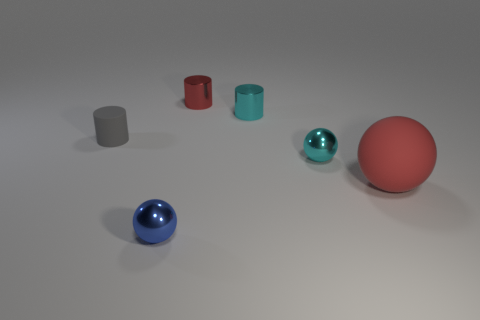Subtract all brown spheres. Subtract all red cylinders. How many spheres are left? 3 Add 4 small gray cylinders. How many objects exist? 10 Subtract 0 purple balls. How many objects are left? 6 Subtract all red metallic cylinders. Subtract all red objects. How many objects are left? 3 Add 1 gray matte cylinders. How many gray matte cylinders are left? 2 Add 3 rubber things. How many rubber things exist? 5 